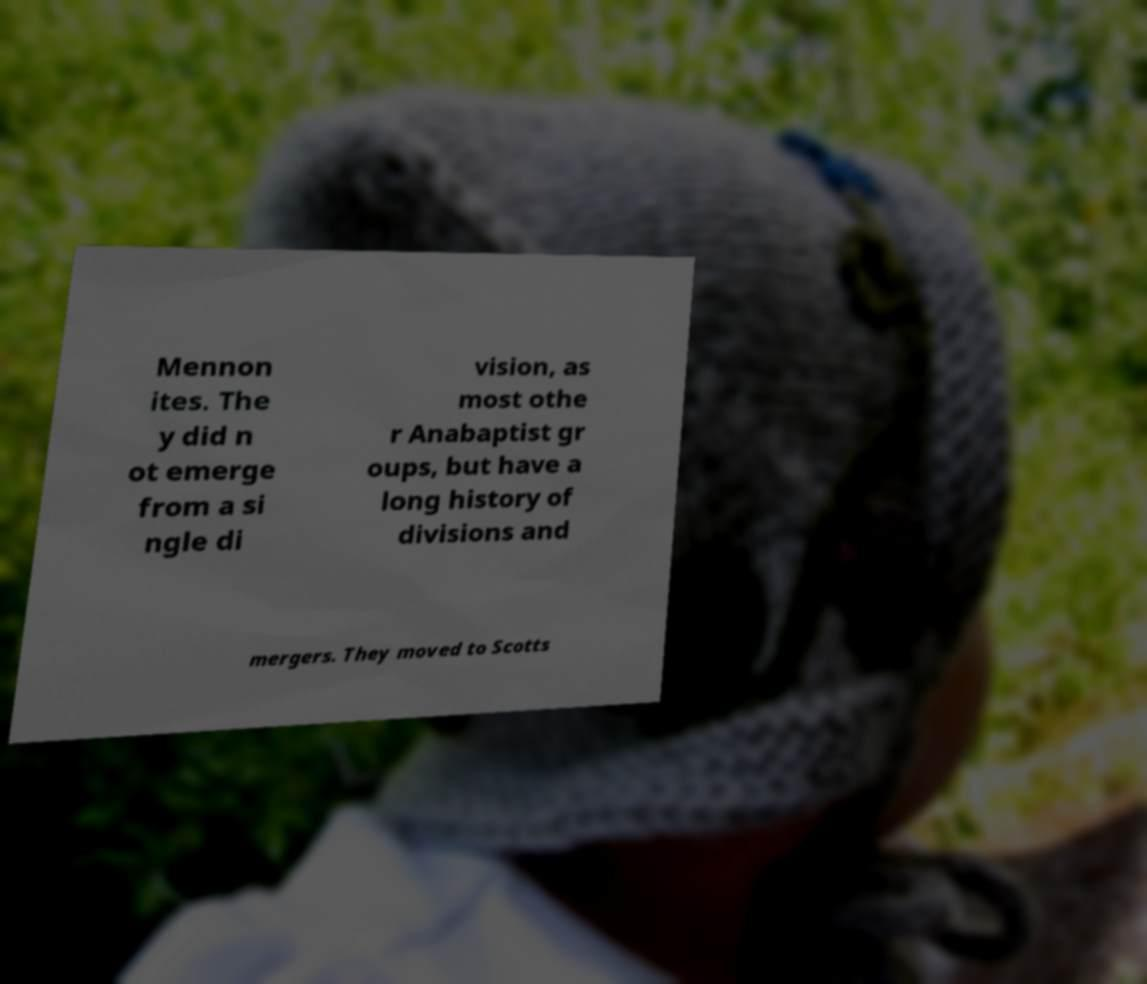Can you read and provide the text displayed in the image?This photo seems to have some interesting text. Can you extract and type it out for me? Mennon ites. The y did n ot emerge from a si ngle di vision, as most othe r Anabaptist gr oups, but have a long history of divisions and mergers. They moved to Scotts 